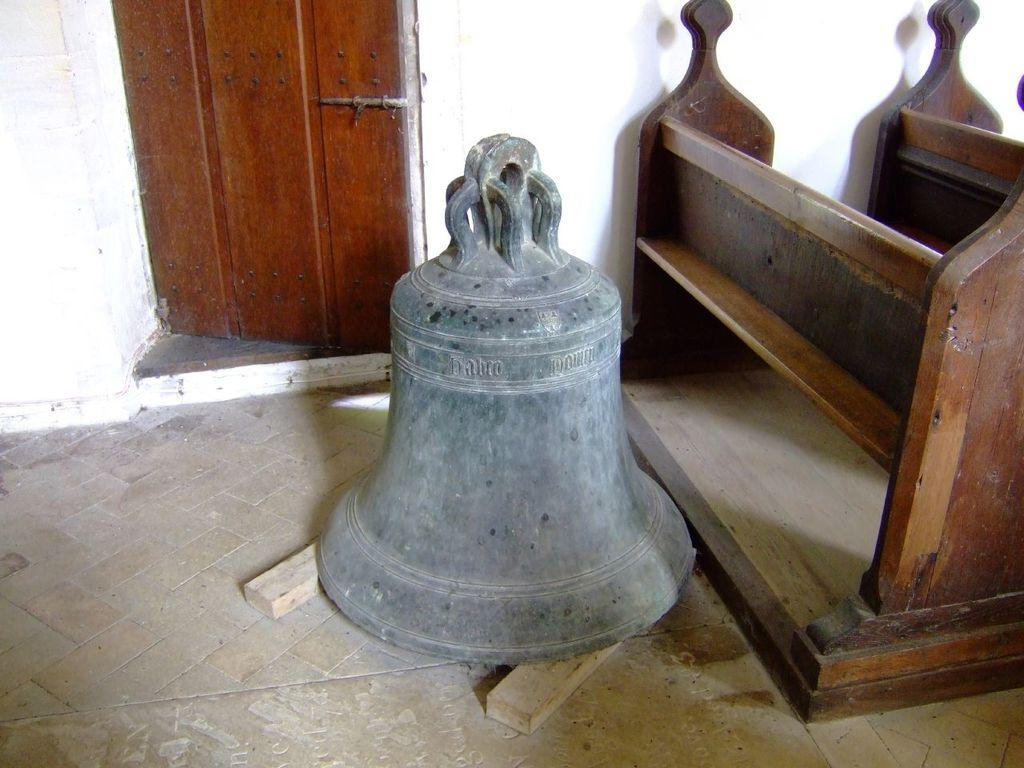What object can be seen hanging in the image? There is a bell in the image. What is located on the floor in the image? There is a wooden object on the floor in the image. What can be seen in the background of the image? There is a door and a wall in the background of the image. What type of pie is being served on the roof in the image? There is no pie or roof present in the image. Can you describe the train that is passing by in the image? There is no train visible in the image. 